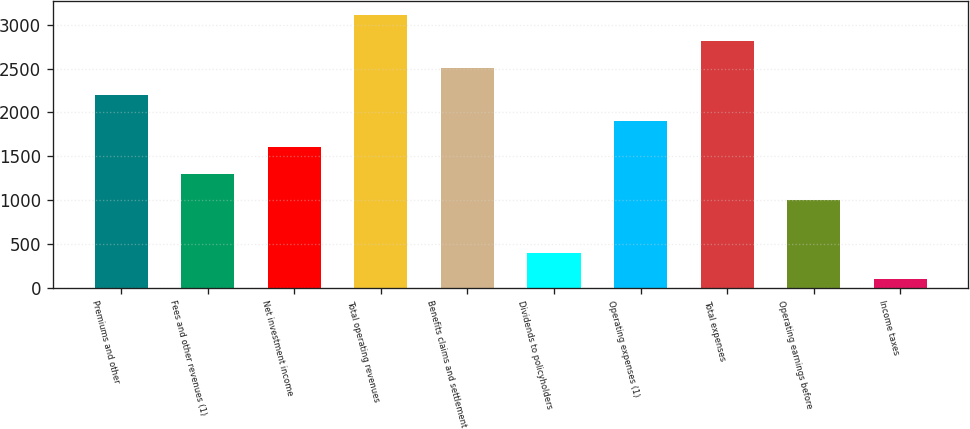<chart> <loc_0><loc_0><loc_500><loc_500><bar_chart><fcel>Premiums and other<fcel>Fees and other revenues (1)<fcel>Net investment income<fcel>Total operating revenues<fcel>Benefits claims and settlement<fcel>Dividends to policyholders<fcel>Operating expenses (1)<fcel>Total expenses<fcel>Operating earnings before<fcel>Income taxes<nl><fcel>2202.68<fcel>1298.96<fcel>1600.2<fcel>3117.04<fcel>2503.92<fcel>395.24<fcel>1901.44<fcel>2815.8<fcel>997.72<fcel>94<nl></chart> 